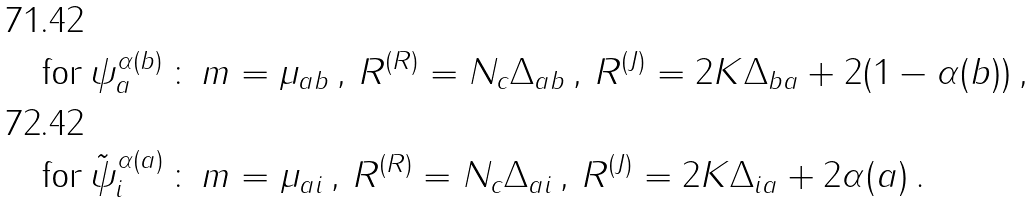<formula> <loc_0><loc_0><loc_500><loc_500>& \text {for\,} \psi ^ { \alpha { ( b ) } } _ { a } \, \colon \, m = \mu _ { a b } \, , \, R ^ { ( R ) } = N _ { c } \Delta _ { a b } \, , \, R ^ { ( J ) } = 2 K \Delta _ { b a } + 2 ( 1 - \alpha { ( b ) } ) \, , \\ & \text {for\,} \tilde { \psi } ^ { \alpha { ( a ) } } _ { i } \, \colon \, m = \mu _ { a i } \, , \, R ^ { ( R ) } = N _ { c } \Delta _ { a i } \, , \, R ^ { ( J ) } = 2 K \Delta _ { i a } + 2 \alpha { ( a ) } \, .</formula> 